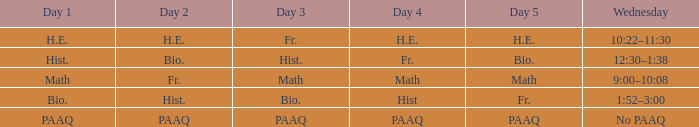What is the Wednesday when day 3 is math? 9:00–10:08. 